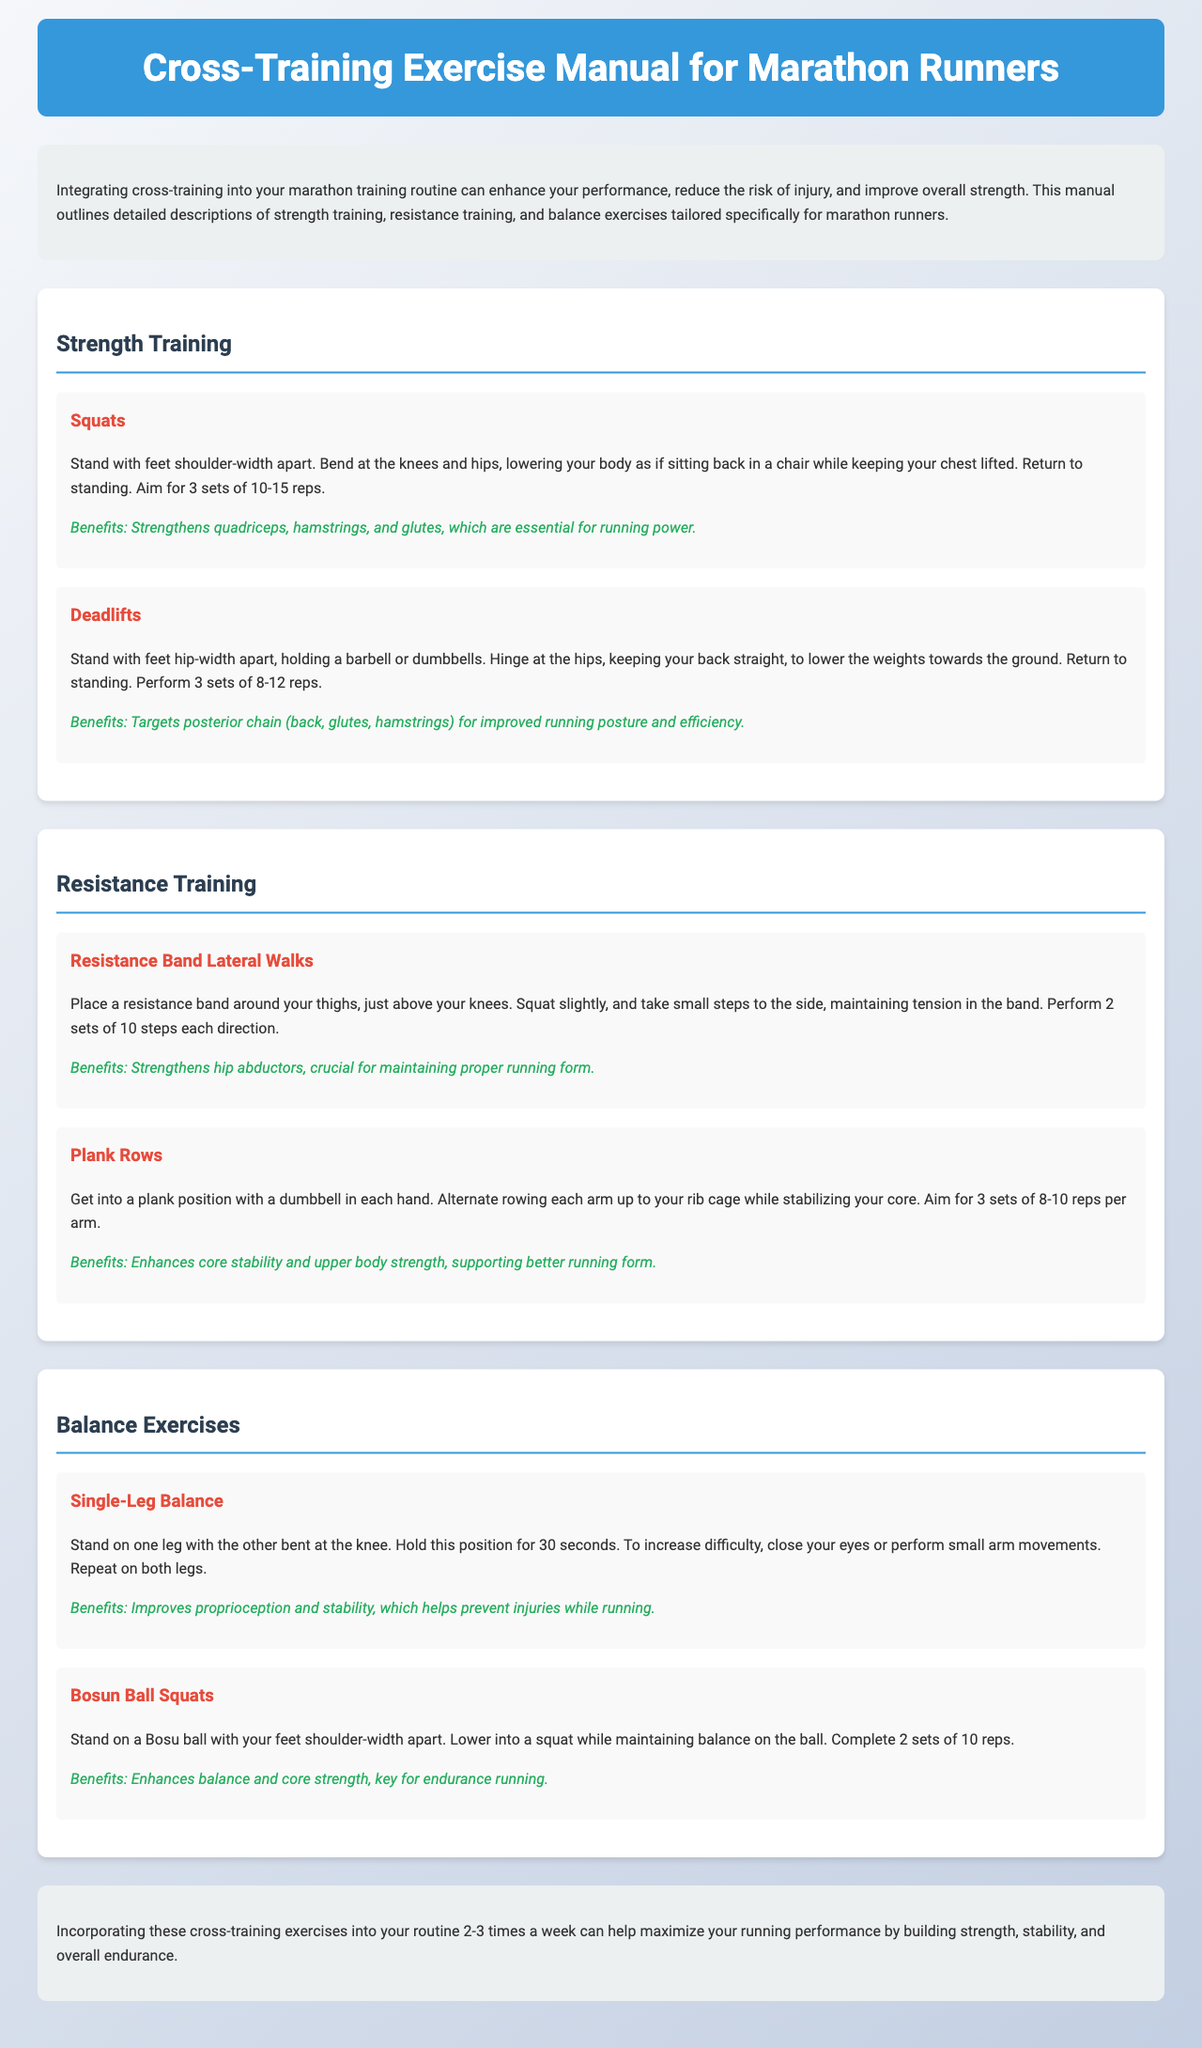What is the purpose of this manual? The purpose of the manual is to enhance performance, reduce the risk of injury, and improve overall strength through cross-training for marathon runners.
Answer: Enhance performance How many sets of squats are suggested? The document specifies performing 3 sets of 10-15 reps for squats.
Answer: 3 sets What do deadlifts target? The document states that deadlifts target the posterior chain, which includes the back, glutes, and hamstrings.
Answer: Posterior chain How many sets and steps are recommended for resistance band lateral walks? The document recommends 2 sets of 10 steps in each direction for resistance band lateral walks.
Answer: 2 sets of 10 steps What benefits do single-leg balances provide? The document mentions that single-leg balances improve proprioception and stability, helping to prevent injuries while running.
Answer: Proprioception and stability What exercise is suggested to enhance balance and core strength? The document suggests Bosu ball squats to enhance balance and core strength.
Answer: Bosu ball squats What type of training does plank rows belong to? Plank rows are categorized under resistance training in the document.
Answer: Resistance training How often should these cross-training exercises be incorporated? The manual recommends incorporating these exercises into the routine 2-3 times a week.
Answer: 2-3 times a week 